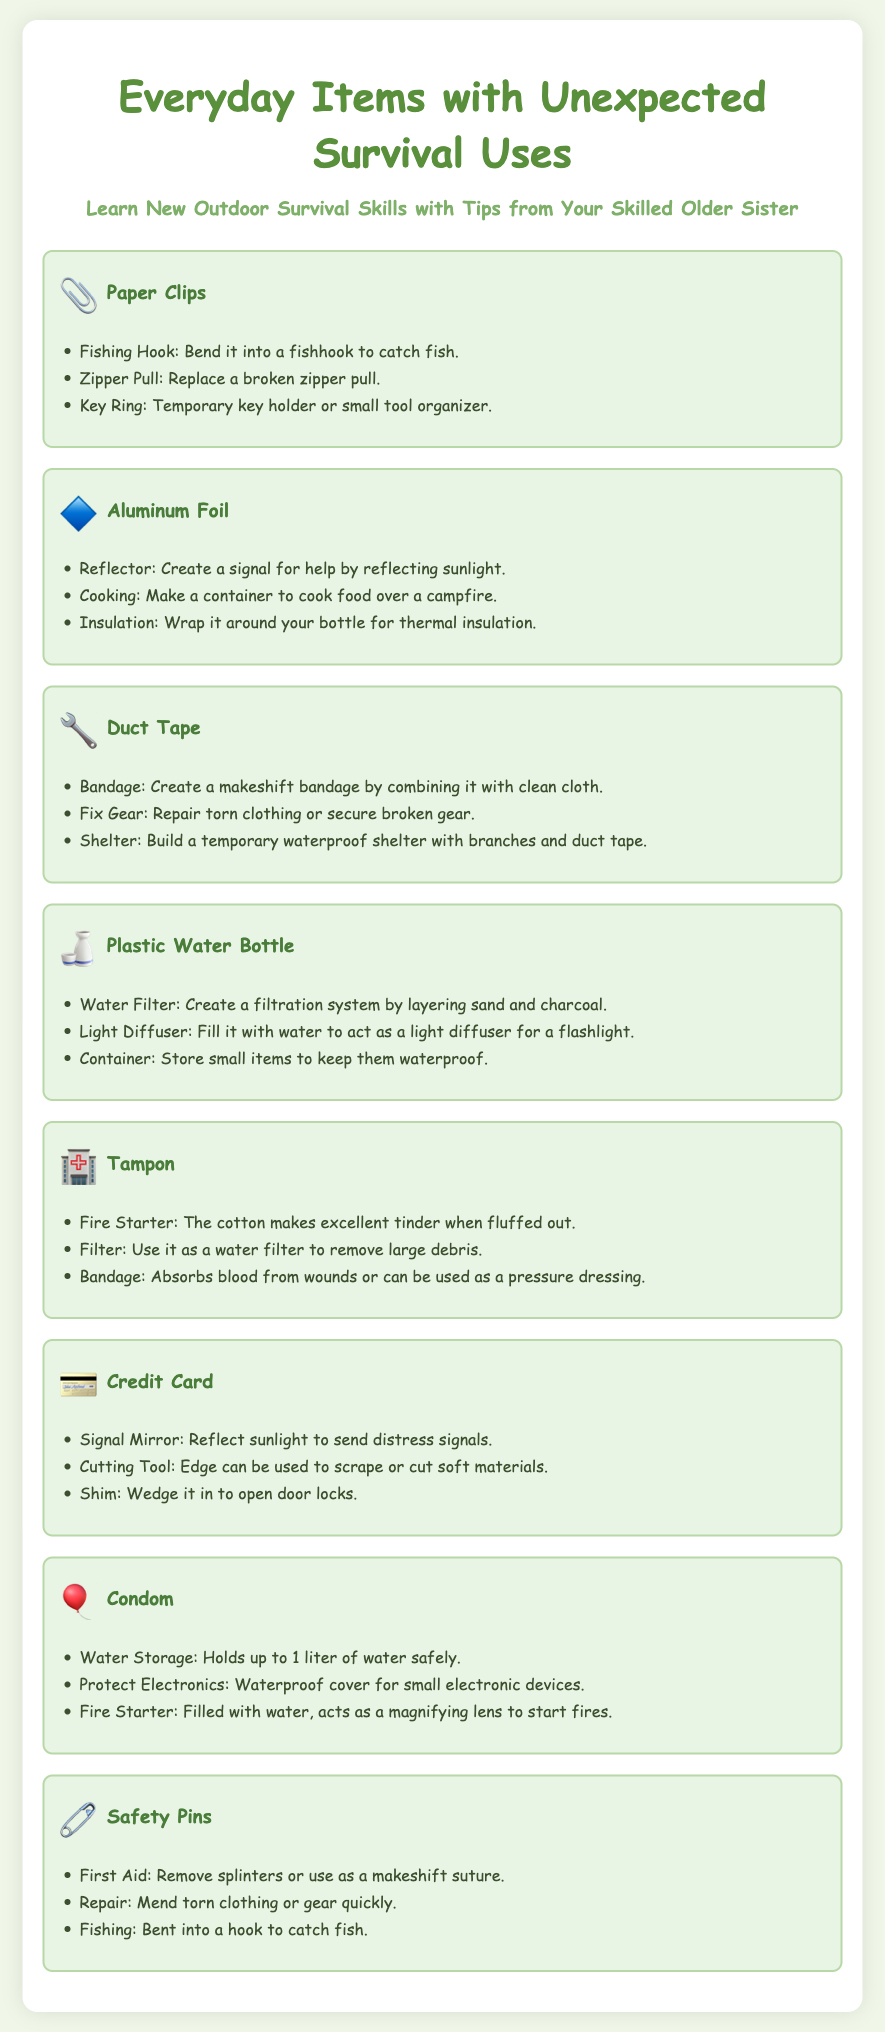What can a paper clip be used as? The paper clip can be used as a fishing hook, zipper pull, or key ring.
Answer: Fishing hook, zipper pull, key ring How can aluminum foil be utilized for cooking? Aluminum foil can be made into a container to cook food over a campfire.
Answer: Container to cook food What are three uses of duct tape listed in the document? Duct tape can be used as a bandage, to fix gear, and to build a shelter.
Answer: Bandage, fix gear, shelter What can a plastic water bottle filter? A plastic water bottle can be used to create a water filtration system.
Answer: Water filtration system How many items are listed in the document? The document lists a total of 8 everyday items with survival uses.
Answer: 8 What is a creative use for a condom in survival situations? A condom can be used for water storage to hold up to 1 liter of water.
Answer: Water storage Which item can be used as a signal mirror? A credit card can be used as a signal mirror.
Answer: Credit card What item can be turned into a makeshift suture? A safety pin can be used as a makeshift suture.
Answer: Safety pin 